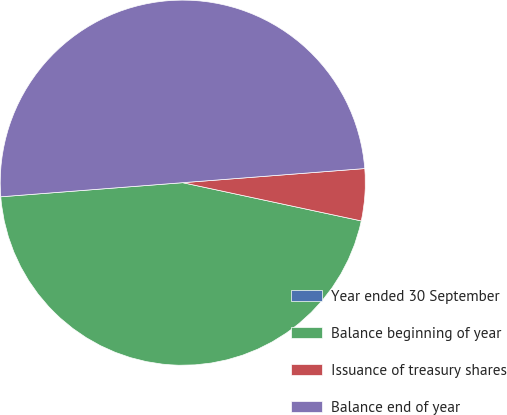<chart> <loc_0><loc_0><loc_500><loc_500><pie_chart><fcel>Year ended 30 September<fcel>Balance beginning of year<fcel>Issuance of treasury shares<fcel>Balance end of year<nl><fcel>0.0%<fcel>45.41%<fcel>4.59%<fcel>50.0%<nl></chart> 